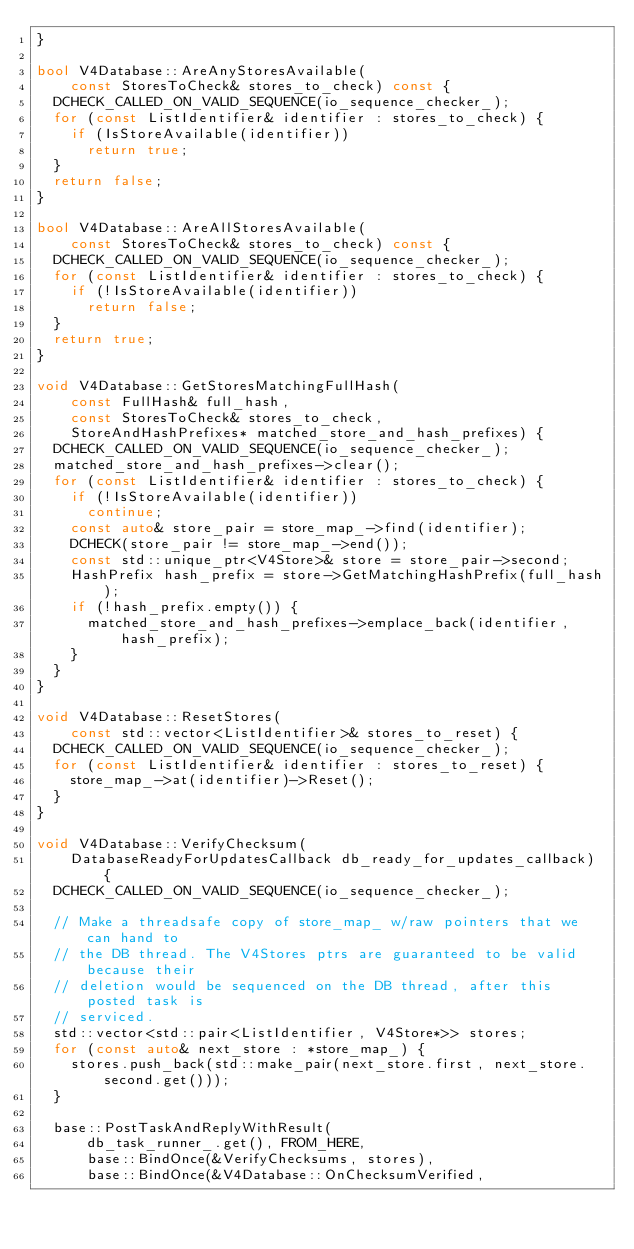<code> <loc_0><loc_0><loc_500><loc_500><_C++_>}

bool V4Database::AreAnyStoresAvailable(
    const StoresToCheck& stores_to_check) const {
  DCHECK_CALLED_ON_VALID_SEQUENCE(io_sequence_checker_);
  for (const ListIdentifier& identifier : stores_to_check) {
    if (IsStoreAvailable(identifier))
      return true;
  }
  return false;
}

bool V4Database::AreAllStoresAvailable(
    const StoresToCheck& stores_to_check) const {
  DCHECK_CALLED_ON_VALID_SEQUENCE(io_sequence_checker_);
  for (const ListIdentifier& identifier : stores_to_check) {
    if (!IsStoreAvailable(identifier))
      return false;
  }
  return true;
}

void V4Database::GetStoresMatchingFullHash(
    const FullHash& full_hash,
    const StoresToCheck& stores_to_check,
    StoreAndHashPrefixes* matched_store_and_hash_prefixes) {
  DCHECK_CALLED_ON_VALID_SEQUENCE(io_sequence_checker_);
  matched_store_and_hash_prefixes->clear();
  for (const ListIdentifier& identifier : stores_to_check) {
    if (!IsStoreAvailable(identifier))
      continue;
    const auto& store_pair = store_map_->find(identifier);
    DCHECK(store_pair != store_map_->end());
    const std::unique_ptr<V4Store>& store = store_pair->second;
    HashPrefix hash_prefix = store->GetMatchingHashPrefix(full_hash);
    if (!hash_prefix.empty()) {
      matched_store_and_hash_prefixes->emplace_back(identifier, hash_prefix);
    }
  }
}

void V4Database::ResetStores(
    const std::vector<ListIdentifier>& stores_to_reset) {
  DCHECK_CALLED_ON_VALID_SEQUENCE(io_sequence_checker_);
  for (const ListIdentifier& identifier : stores_to_reset) {
    store_map_->at(identifier)->Reset();
  }
}

void V4Database::VerifyChecksum(
    DatabaseReadyForUpdatesCallback db_ready_for_updates_callback) {
  DCHECK_CALLED_ON_VALID_SEQUENCE(io_sequence_checker_);

  // Make a threadsafe copy of store_map_ w/raw pointers that we can hand to
  // the DB thread. The V4Stores ptrs are guaranteed to be valid because their
  // deletion would be sequenced on the DB thread, after this posted task is
  // serviced.
  std::vector<std::pair<ListIdentifier, V4Store*>> stores;
  for (const auto& next_store : *store_map_) {
    stores.push_back(std::make_pair(next_store.first, next_store.second.get()));
  }

  base::PostTaskAndReplyWithResult(
      db_task_runner_.get(), FROM_HERE,
      base::BindOnce(&VerifyChecksums, stores),
      base::BindOnce(&V4Database::OnChecksumVerified,</code> 